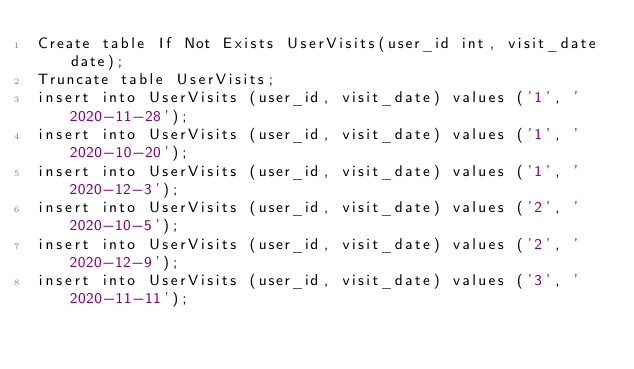<code> <loc_0><loc_0><loc_500><loc_500><_SQL_>Create table If Not Exists UserVisits(user_id int, visit_date date);
Truncate table UserVisits;
insert into UserVisits (user_id, visit_date) values ('1', '2020-11-28');
insert into UserVisits (user_id, visit_date) values ('1', '2020-10-20');
insert into UserVisits (user_id, visit_date) values ('1', '2020-12-3');
insert into UserVisits (user_id, visit_date) values ('2', '2020-10-5');
insert into UserVisits (user_id, visit_date) values ('2', '2020-12-9');
insert into UserVisits (user_id, visit_date) values ('3', '2020-11-11');
</code> 